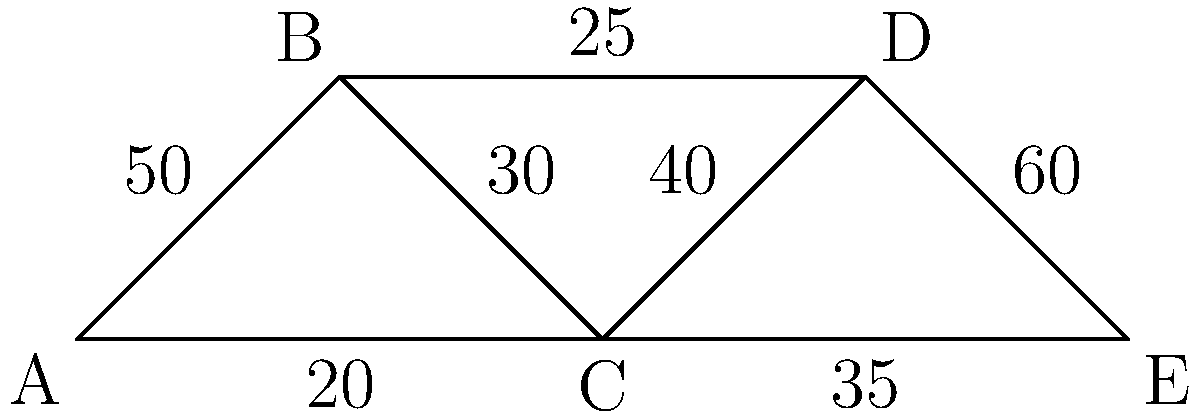Analyze the supply chain network graph above, where nodes represent distribution centers and edges represent transportation routes with their respective capacities (in units per day). Which transportation route represents the most critical bottleneck in the overall flow from node A to node E? To identify the most critical bottleneck in the supply chain network from node A to node E, we need to analyze all possible paths and their capacities:

1. Path A-B-C-D-E:
   Minimum capacity = min(50, 30, 40, 60) = 30

2. Path A-B-C-E:
   Minimum capacity = min(50, 30, 35) = 30

3. Path A-B-D-E:
   Minimum capacity = min(50, 25, 60) = 25

4. Path A-C-D-E:
   Minimum capacity = min(20, 40, 60) = 20

5. Path A-C-E:
   Minimum capacity = min(20, 35) = 20

The overall maximum flow from A to E is determined by the sum of flows through independent paths. The two independent paths with the highest combined capacity are:

1. A-B-C-E: 30 units/day
2. A-C-D-E: 20 units/day

Total maximum flow = 30 + 20 = 50 units/day

The bottleneck in this network is the route that, if improved, would increase the overall flow the most. In this case, it's the A-C route with a capacity of 20 units/day. Increasing this capacity would directly increase the overall network flow.
Answer: A-C route (20 units/day) 